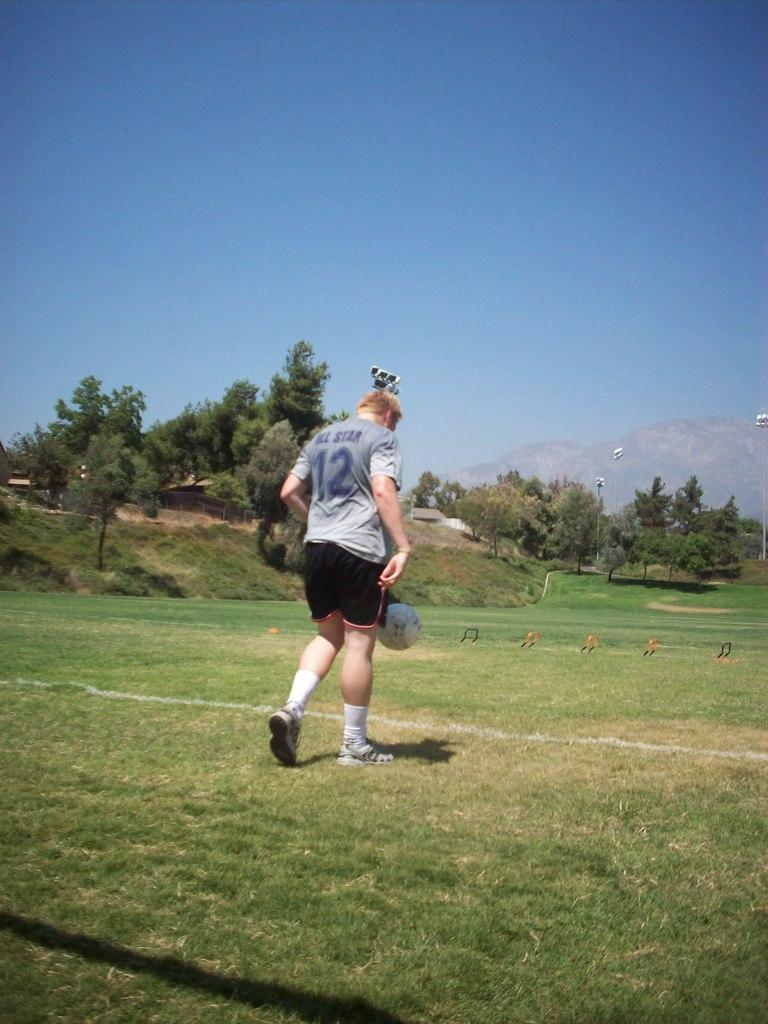Provide a one-sentence caption for the provided image. A man wearing a shirt with All Star 12 on it. 